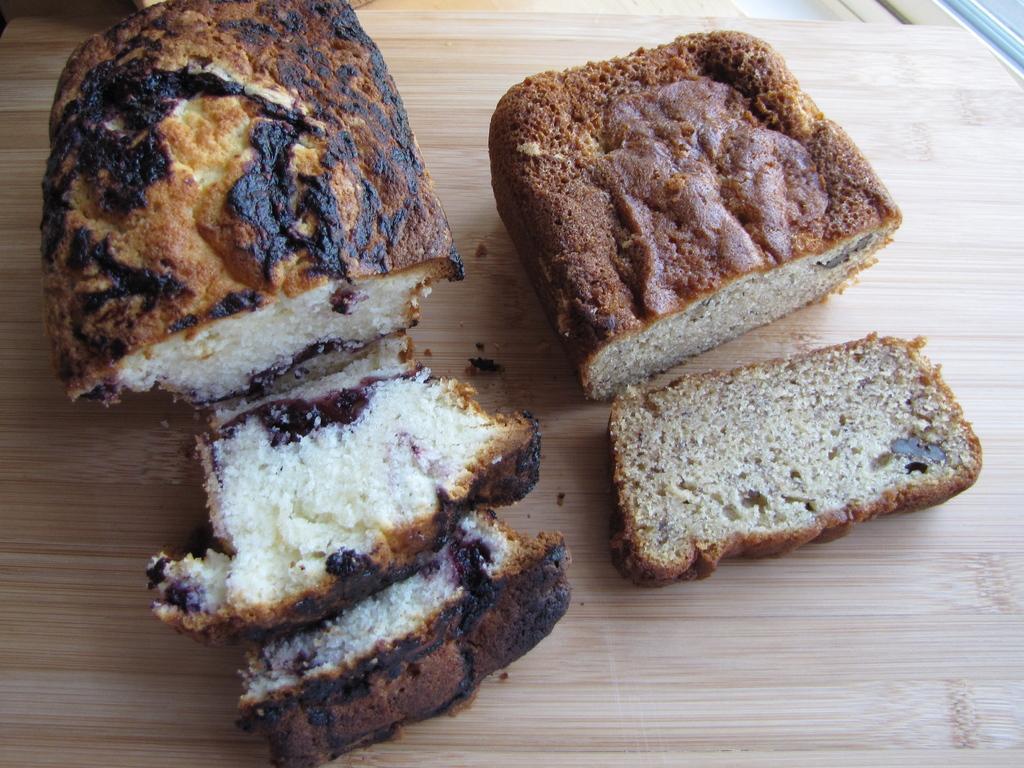In one or two sentences, can you explain what this image depicts? In this image we can see some food on the table. 